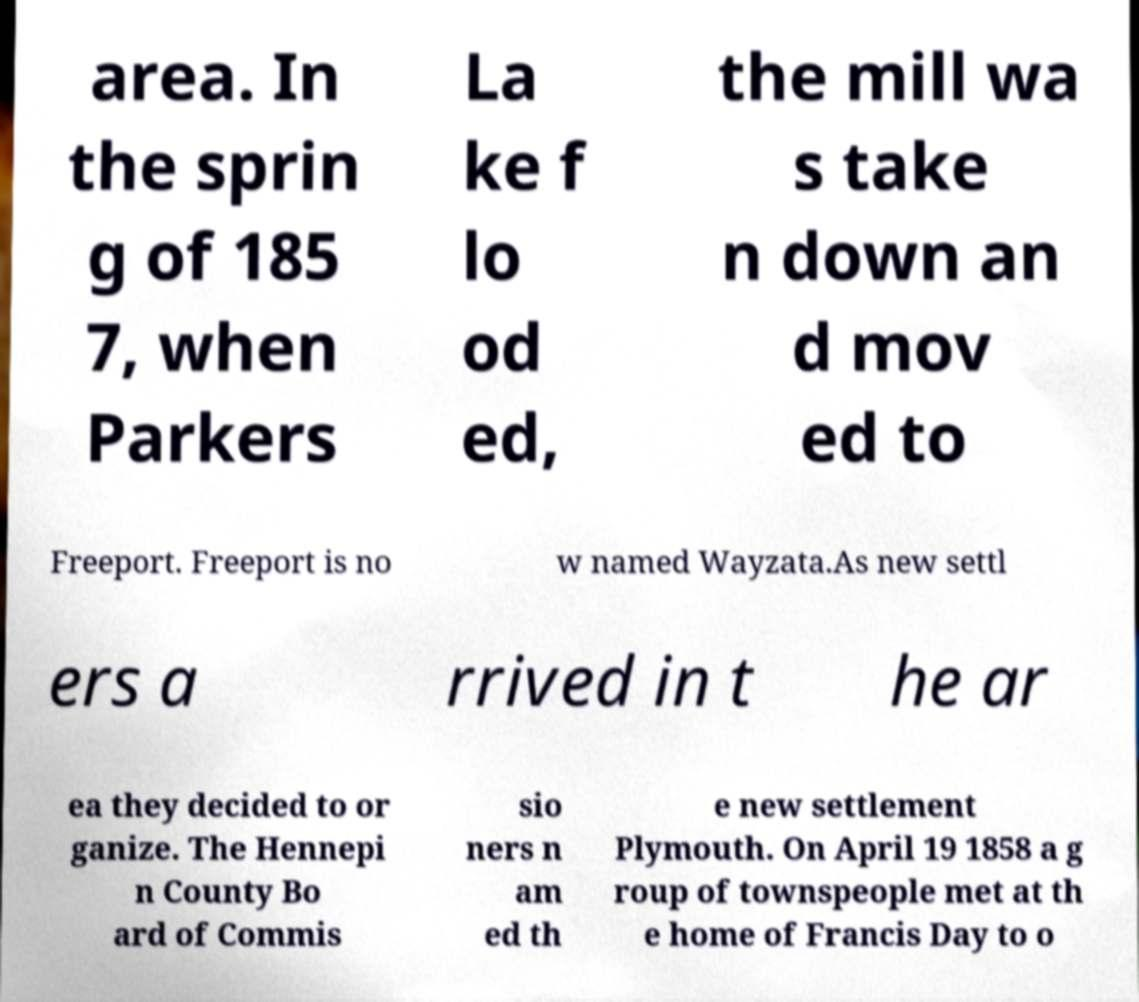Please identify and transcribe the text found in this image. area. In the sprin g of 185 7, when Parkers La ke f lo od ed, the mill wa s take n down an d mov ed to Freeport. Freeport is no w named Wayzata.As new settl ers a rrived in t he ar ea they decided to or ganize. The Hennepi n County Bo ard of Commis sio ners n am ed th e new settlement Plymouth. On April 19 1858 a g roup of townspeople met at th e home of Francis Day to o 